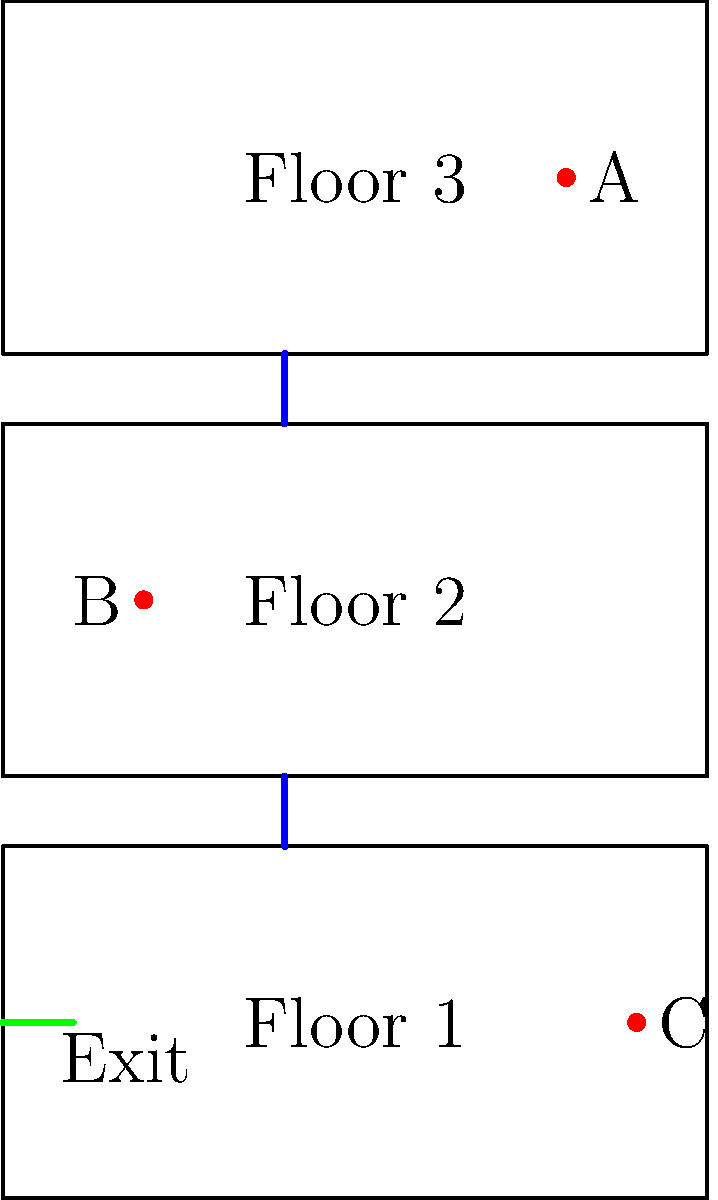As a parenting influencer, you're organizing a family safety workshop. Using the provided floor plan of a three-story building, determine the most efficient evacuation route for person A on the third floor. How many floors does person A need to descend to reach the exit? To determine the most efficient evacuation route for person A, we need to analyze the floor plan:

1. Locate person A: Person A is on the third floor (top floor) near the right side of the building.

2. Identify the stairs: There are two sets of stairs connecting the floors, located on the left side of the building.

3. Locate the exit: The exit is on the first floor (bottom floor) on the left side of the building.

4. Plan the route:
   a. Person A needs to move left on the third floor to reach the stairs.
   b. Descend the stairs from the third floor to the second floor.
   c. Continue down the stairs from the second floor to the first floor.
   d. On the first floor, move slightly left to reach the exit.

5. Count the floors descended:
   - From third floor to second floor: 1 floor
   - From second floor to first floor: 1 floor
   
   Total floors descended: 1 + 1 = 2 floors

Therefore, person A needs to descend 2 floors to reach the exit for the most efficient evacuation route.
Answer: 2 floors 